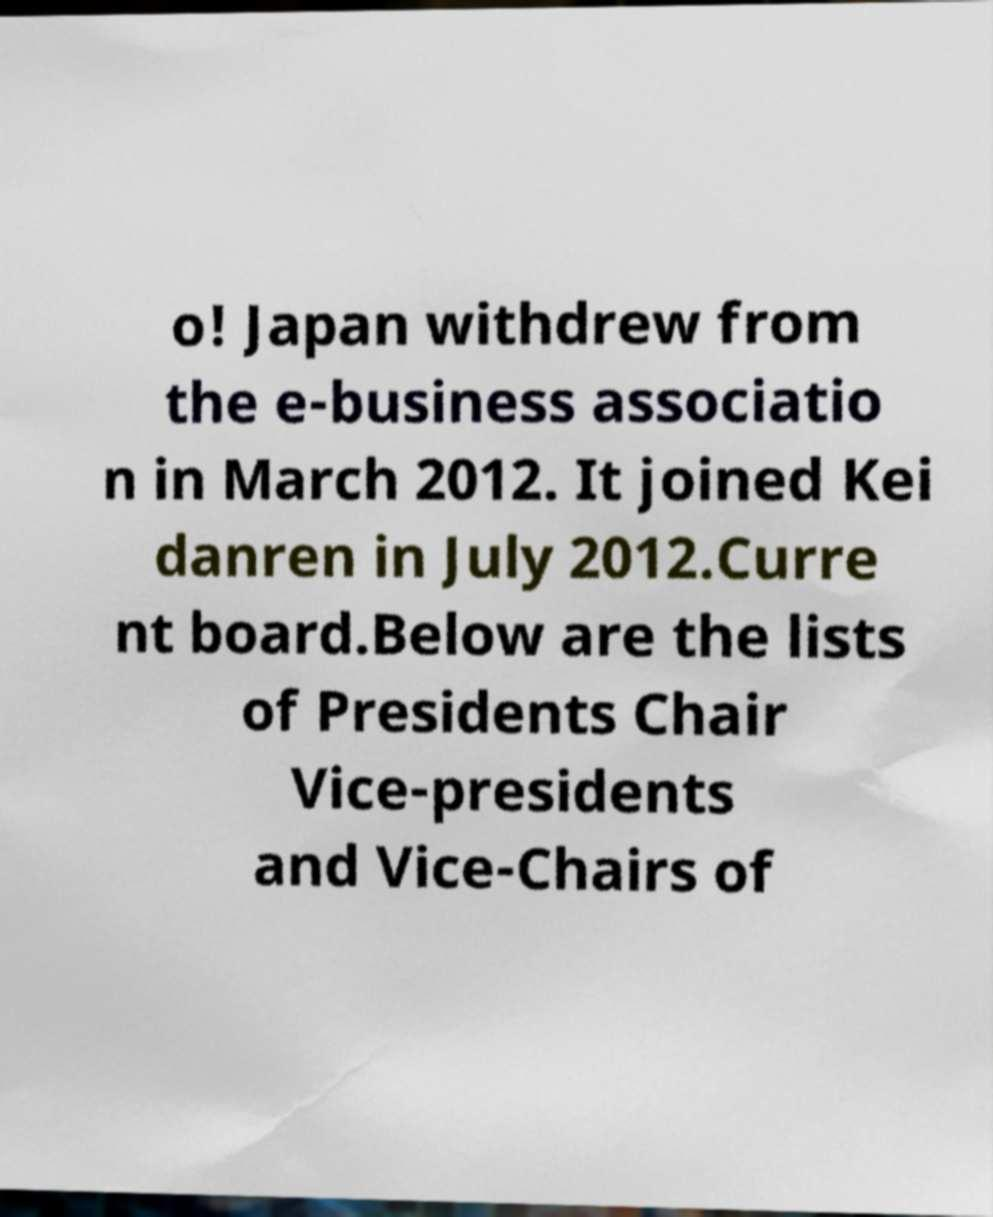Please read and relay the text visible in this image. What does it say? o! Japan withdrew from the e-business associatio n in March 2012. It joined Kei danren in July 2012.Curre nt board.Below are the lists of Presidents Chair Vice-presidents and Vice-Chairs of 